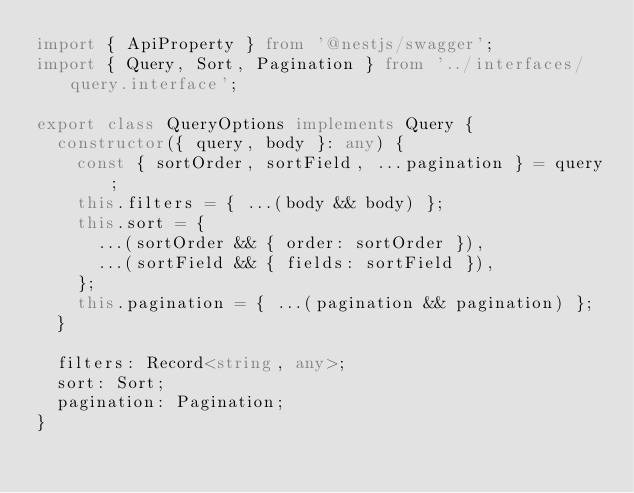<code> <loc_0><loc_0><loc_500><loc_500><_TypeScript_>import { ApiProperty } from '@nestjs/swagger';
import { Query, Sort, Pagination } from '../interfaces/query.interface';

export class QueryOptions implements Query {
  constructor({ query, body }: any) {
    const { sortOrder, sortField, ...pagination } = query;
    this.filters = { ...(body && body) };
    this.sort = {
      ...(sortOrder && { order: sortOrder }),
      ...(sortField && { fields: sortField }),
    };
    this.pagination = { ...(pagination && pagination) };
  }

  filters: Record<string, any>;
  sort: Sort;
  pagination: Pagination;
}
</code> 